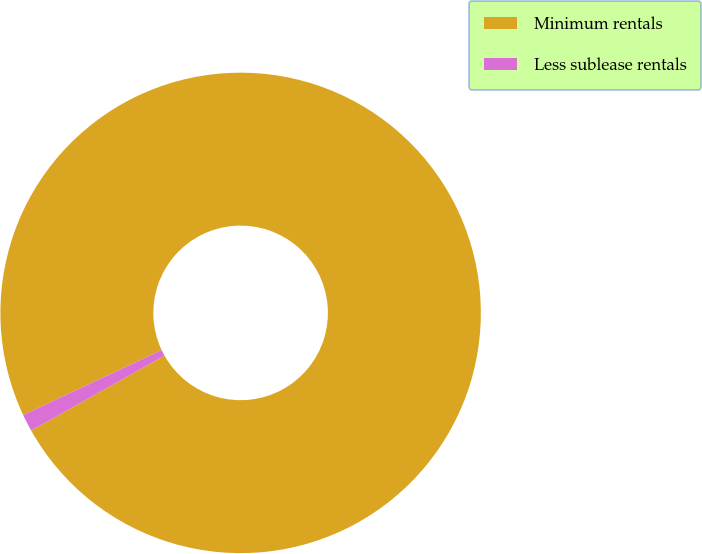<chart> <loc_0><loc_0><loc_500><loc_500><pie_chart><fcel>Minimum rentals<fcel>Less sublease rentals<nl><fcel>98.84%<fcel>1.16%<nl></chart> 